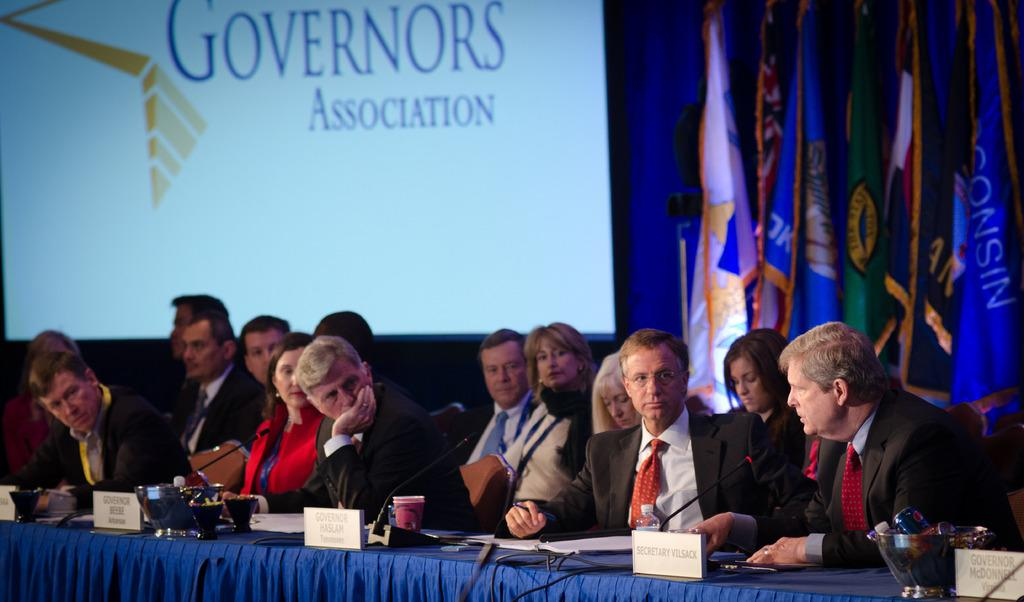What are the people in the image doing? There is a group of people sitting on chairs in the image. What is on the table in front of the people? There is a board, a cup, a microphone, and a bowl on the table. What can be seen at the back of the image? There are flags and a screen visible at the back side of the image. What type of magic is being performed by the people in the image? There is no indication of magic being performed in the image. 